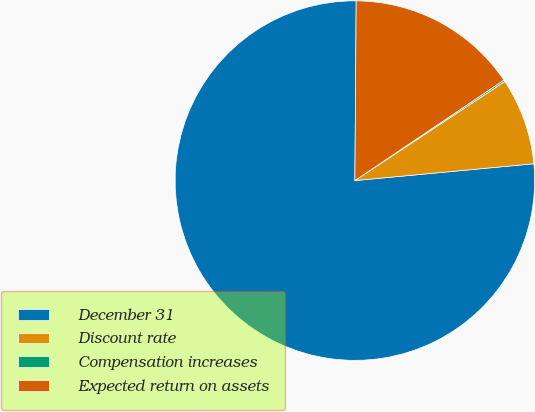Convert chart. <chart><loc_0><loc_0><loc_500><loc_500><pie_chart><fcel>December 31<fcel>Discount rate<fcel>Compensation increases<fcel>Expected return on assets<nl><fcel>76.61%<fcel>7.8%<fcel>0.15%<fcel>15.44%<nl></chart> 